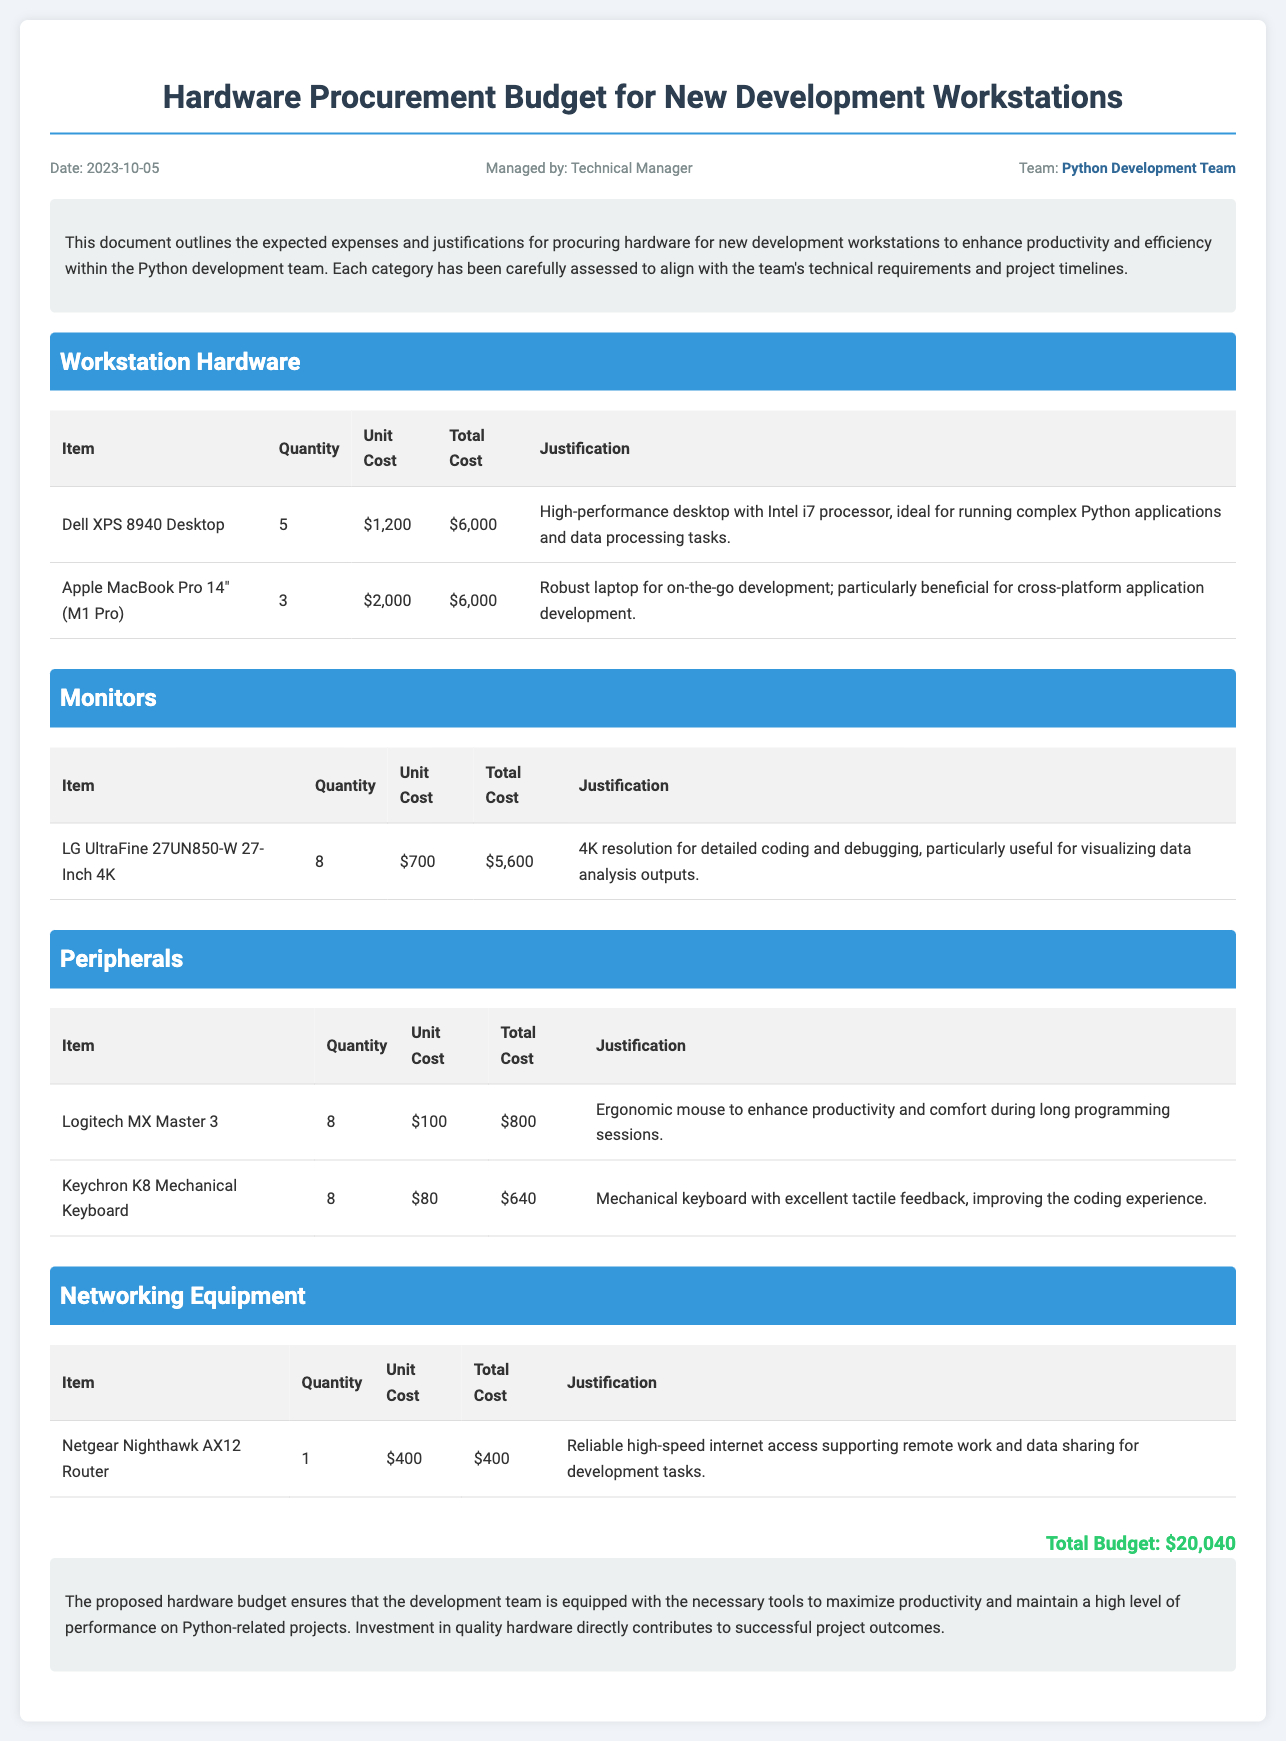What is the date of the document? The date of the document is mentioned in the header as 2023-10-05.
Answer: 2023-10-05 How many Dell XPS 8940 Desktops are being procured? The quantity of Dell XPS 8940 Desktops listed in the workstation hardware section is 5.
Answer: 5 What is the total cost for the LG UltraFine 27UN850-W monitors? The total cost for the monitors is calculated as 8 units at $700 each, which equals $5,600.
Answer: $5,600 What is the justification for the Logitech MX Master 3 mouse? The justification provided states it is an ergonomic mouse to enhance productivity and comfort during long programming sessions.
Answer: Ergonomic mouse to enhance productivity What is the total budget for hardware procurement? The total budget is summarized at the bottom of the document as $20,040.
Answer: $20,040 Why is the Apple MacBook Pro recommended for purchase? The justification mentions it is a robust laptop for on-the-go development, beneficial for cross-platform application development.
Answer: On-the-go development How many Keychron K8 Mechanical Keyboards are included in the budget? The document states that 8 Keychron K8 Mechanical Keyboards are included in the peripherals section.
Answer: 8 What type of router is being procured? The type of router mentioned is the Netgear Nighthawk AX12 Router, specified in the networking equipment section.
Answer: Netgear Nighthawk AX12 Router What color is highlighted for the Python Development Team? The color highlighted for the team is blue, used for emphasis in the document.
Answer: Blue 